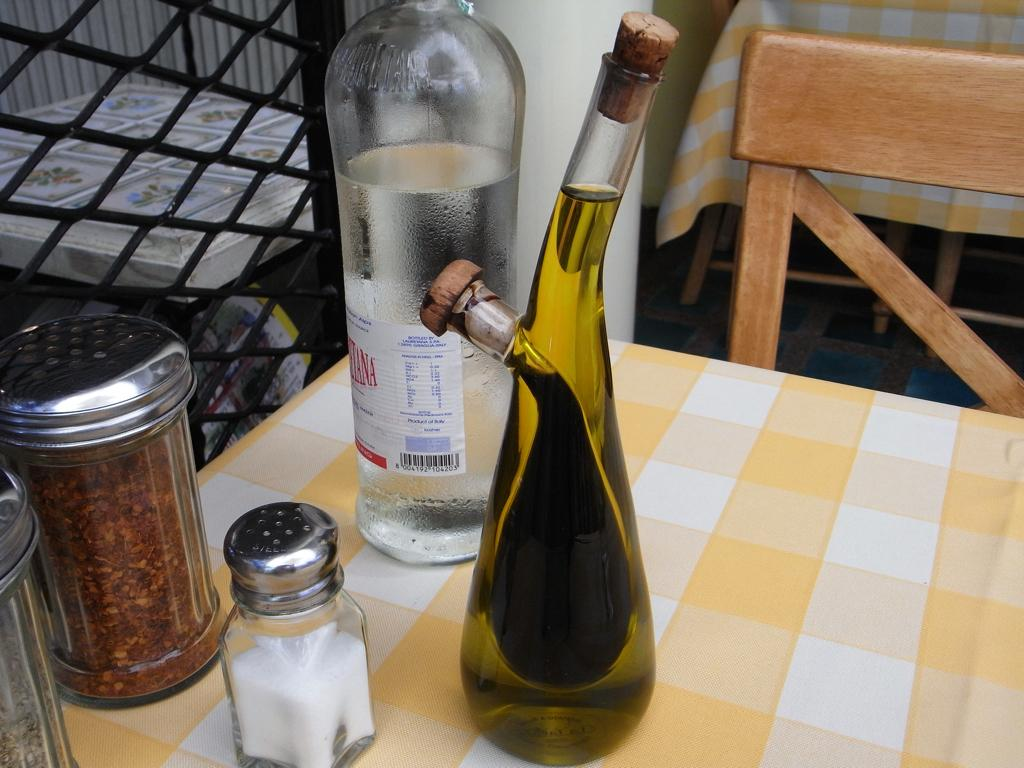What objects are on the table in the image? There are bottles on a table in the image. What piece of furniture is near the table? There is a chair near the table in the image. How many goldfish are swimming in the bottle on the table? There are no goldfish present in the image; it only shows bottles on a table. 